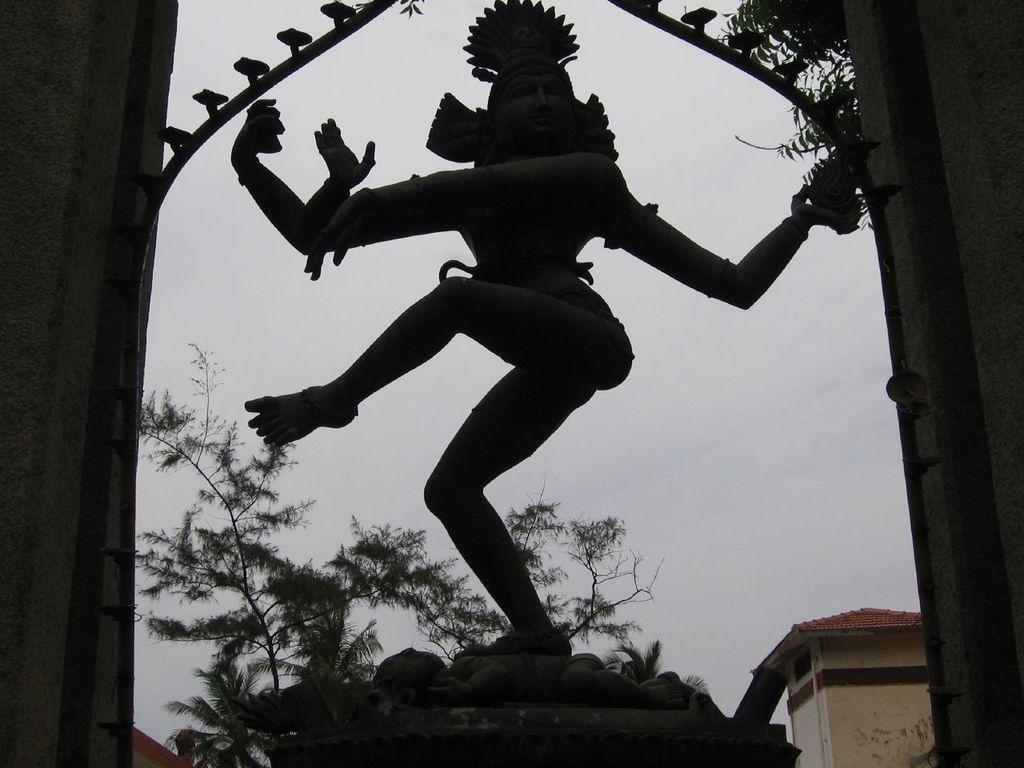Please provide a concise description of this image. In this image we can see a statue on the pedestal. In the background we can see walls, trees, building and sky. 